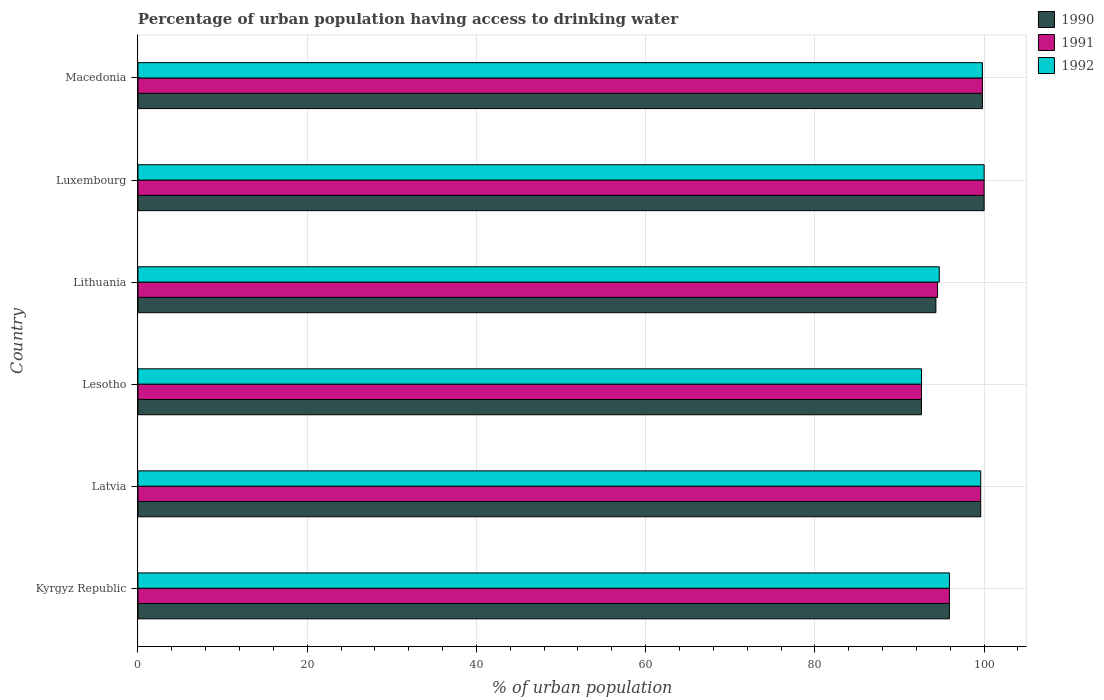How many groups of bars are there?
Provide a short and direct response. 6. Are the number of bars per tick equal to the number of legend labels?
Offer a very short reply. Yes. Are the number of bars on each tick of the Y-axis equal?
Make the answer very short. Yes. How many bars are there on the 3rd tick from the bottom?
Ensure brevity in your answer.  3. What is the label of the 4th group of bars from the top?
Provide a short and direct response. Lesotho. In how many cases, is the number of bars for a given country not equal to the number of legend labels?
Your response must be concise. 0. What is the percentage of urban population having access to drinking water in 1990 in Lithuania?
Ensure brevity in your answer.  94.3. Across all countries, what is the minimum percentage of urban population having access to drinking water in 1991?
Keep it short and to the point. 92.6. In which country was the percentage of urban population having access to drinking water in 1991 maximum?
Your answer should be compact. Luxembourg. In which country was the percentage of urban population having access to drinking water in 1992 minimum?
Make the answer very short. Lesotho. What is the total percentage of urban population having access to drinking water in 1990 in the graph?
Your answer should be very brief. 582.2. What is the difference between the percentage of urban population having access to drinking water in 1990 in Latvia and that in Lithuania?
Give a very brief answer. 5.3. What is the difference between the percentage of urban population having access to drinking water in 1991 in Macedonia and the percentage of urban population having access to drinking water in 1990 in Lithuania?
Your answer should be very brief. 5.5. What is the average percentage of urban population having access to drinking water in 1990 per country?
Ensure brevity in your answer.  97.03. What is the difference between the percentage of urban population having access to drinking water in 1990 and percentage of urban population having access to drinking water in 1991 in Macedonia?
Provide a short and direct response. 0. In how many countries, is the percentage of urban population having access to drinking water in 1990 greater than 76 %?
Your response must be concise. 6. What is the ratio of the percentage of urban population having access to drinking water in 1992 in Luxembourg to that in Macedonia?
Provide a succinct answer. 1. Is the difference between the percentage of urban population having access to drinking water in 1990 in Latvia and Lithuania greater than the difference between the percentage of urban population having access to drinking water in 1991 in Latvia and Lithuania?
Your answer should be very brief. Yes. What is the difference between the highest and the second highest percentage of urban population having access to drinking water in 1992?
Make the answer very short. 0.2. What is the difference between the highest and the lowest percentage of urban population having access to drinking water in 1991?
Your answer should be very brief. 7.4. In how many countries, is the percentage of urban population having access to drinking water in 1990 greater than the average percentage of urban population having access to drinking water in 1990 taken over all countries?
Ensure brevity in your answer.  3. Is the sum of the percentage of urban population having access to drinking water in 1991 in Lithuania and Luxembourg greater than the maximum percentage of urban population having access to drinking water in 1992 across all countries?
Provide a succinct answer. Yes. What does the 1st bar from the bottom in Luxembourg represents?
Your response must be concise. 1990. Is it the case that in every country, the sum of the percentage of urban population having access to drinking water in 1990 and percentage of urban population having access to drinking water in 1991 is greater than the percentage of urban population having access to drinking water in 1992?
Give a very brief answer. Yes. Are all the bars in the graph horizontal?
Offer a very short reply. Yes. How many countries are there in the graph?
Offer a terse response. 6. Are the values on the major ticks of X-axis written in scientific E-notation?
Your answer should be very brief. No. Does the graph contain any zero values?
Your response must be concise. No. What is the title of the graph?
Provide a succinct answer. Percentage of urban population having access to drinking water. What is the label or title of the X-axis?
Give a very brief answer. % of urban population. What is the label or title of the Y-axis?
Provide a succinct answer. Country. What is the % of urban population in 1990 in Kyrgyz Republic?
Your response must be concise. 95.9. What is the % of urban population of 1991 in Kyrgyz Republic?
Provide a succinct answer. 95.9. What is the % of urban population in 1992 in Kyrgyz Republic?
Provide a short and direct response. 95.9. What is the % of urban population of 1990 in Latvia?
Give a very brief answer. 99.6. What is the % of urban population in 1991 in Latvia?
Your answer should be very brief. 99.6. What is the % of urban population in 1992 in Latvia?
Offer a terse response. 99.6. What is the % of urban population in 1990 in Lesotho?
Your answer should be compact. 92.6. What is the % of urban population in 1991 in Lesotho?
Give a very brief answer. 92.6. What is the % of urban population of 1992 in Lesotho?
Offer a very short reply. 92.6. What is the % of urban population in 1990 in Lithuania?
Offer a terse response. 94.3. What is the % of urban population in 1991 in Lithuania?
Ensure brevity in your answer.  94.5. What is the % of urban population in 1992 in Lithuania?
Offer a terse response. 94.7. What is the % of urban population in 1990 in Macedonia?
Your answer should be very brief. 99.8. What is the % of urban population in 1991 in Macedonia?
Offer a terse response. 99.8. What is the % of urban population in 1992 in Macedonia?
Provide a short and direct response. 99.8. Across all countries, what is the maximum % of urban population of 1991?
Give a very brief answer. 100. Across all countries, what is the maximum % of urban population of 1992?
Provide a succinct answer. 100. Across all countries, what is the minimum % of urban population in 1990?
Offer a very short reply. 92.6. Across all countries, what is the minimum % of urban population in 1991?
Offer a terse response. 92.6. Across all countries, what is the minimum % of urban population in 1992?
Offer a very short reply. 92.6. What is the total % of urban population in 1990 in the graph?
Ensure brevity in your answer.  582.2. What is the total % of urban population in 1991 in the graph?
Provide a succinct answer. 582.4. What is the total % of urban population in 1992 in the graph?
Your response must be concise. 582.6. What is the difference between the % of urban population of 1991 in Kyrgyz Republic and that in Latvia?
Provide a succinct answer. -3.7. What is the difference between the % of urban population of 1990 in Kyrgyz Republic and that in Lesotho?
Make the answer very short. 3.3. What is the difference between the % of urban population of 1990 in Kyrgyz Republic and that in Lithuania?
Offer a terse response. 1.6. What is the difference between the % of urban population of 1991 in Kyrgyz Republic and that in Lithuania?
Your answer should be very brief. 1.4. What is the difference between the % of urban population of 1990 in Kyrgyz Republic and that in Luxembourg?
Offer a terse response. -4.1. What is the difference between the % of urban population of 1990 in Kyrgyz Republic and that in Macedonia?
Your answer should be very brief. -3.9. What is the difference between the % of urban population in 1991 in Kyrgyz Republic and that in Macedonia?
Your response must be concise. -3.9. What is the difference between the % of urban population in 1991 in Latvia and that in Lesotho?
Provide a succinct answer. 7. What is the difference between the % of urban population in 1992 in Latvia and that in Lesotho?
Make the answer very short. 7. What is the difference between the % of urban population of 1990 in Latvia and that in Lithuania?
Your response must be concise. 5.3. What is the difference between the % of urban population in 1991 in Latvia and that in Lithuania?
Offer a very short reply. 5.1. What is the difference between the % of urban population of 1990 in Latvia and that in Luxembourg?
Offer a terse response. -0.4. What is the difference between the % of urban population in 1991 in Latvia and that in Luxembourg?
Offer a very short reply. -0.4. What is the difference between the % of urban population in 1992 in Latvia and that in Luxembourg?
Your answer should be very brief. -0.4. What is the difference between the % of urban population in 1990 in Latvia and that in Macedonia?
Ensure brevity in your answer.  -0.2. What is the difference between the % of urban population in 1992 in Latvia and that in Macedonia?
Provide a short and direct response. -0.2. What is the difference between the % of urban population of 1992 in Lesotho and that in Lithuania?
Your response must be concise. -2.1. What is the difference between the % of urban population in 1991 in Lesotho and that in Luxembourg?
Your answer should be compact. -7.4. What is the difference between the % of urban population in 1992 in Lesotho and that in Luxembourg?
Provide a succinct answer. -7.4. What is the difference between the % of urban population in 1990 in Lesotho and that in Macedonia?
Offer a terse response. -7.2. What is the difference between the % of urban population of 1991 in Lesotho and that in Macedonia?
Your answer should be very brief. -7.2. What is the difference between the % of urban population of 1992 in Lesotho and that in Macedonia?
Provide a succinct answer. -7.2. What is the difference between the % of urban population of 1991 in Lithuania and that in Luxembourg?
Give a very brief answer. -5.5. What is the difference between the % of urban population of 1990 in Lithuania and that in Macedonia?
Keep it short and to the point. -5.5. What is the difference between the % of urban population of 1990 in Luxembourg and that in Macedonia?
Offer a very short reply. 0.2. What is the difference between the % of urban population of 1991 in Luxembourg and that in Macedonia?
Make the answer very short. 0.2. What is the difference between the % of urban population of 1992 in Luxembourg and that in Macedonia?
Make the answer very short. 0.2. What is the difference between the % of urban population of 1990 in Kyrgyz Republic and the % of urban population of 1991 in Latvia?
Ensure brevity in your answer.  -3.7. What is the difference between the % of urban population in 1990 in Kyrgyz Republic and the % of urban population in 1992 in Latvia?
Offer a very short reply. -3.7. What is the difference between the % of urban population of 1990 in Kyrgyz Republic and the % of urban population of 1991 in Lesotho?
Ensure brevity in your answer.  3.3. What is the difference between the % of urban population in 1991 in Kyrgyz Republic and the % of urban population in 1992 in Lesotho?
Provide a short and direct response. 3.3. What is the difference between the % of urban population of 1991 in Kyrgyz Republic and the % of urban population of 1992 in Lithuania?
Make the answer very short. 1.2. What is the difference between the % of urban population in 1990 in Kyrgyz Republic and the % of urban population in 1991 in Luxembourg?
Your answer should be very brief. -4.1. What is the difference between the % of urban population in 1990 in Kyrgyz Republic and the % of urban population in 1991 in Macedonia?
Offer a terse response. -3.9. What is the difference between the % of urban population in 1990 in Kyrgyz Republic and the % of urban population in 1992 in Macedonia?
Offer a terse response. -3.9. What is the difference between the % of urban population in 1990 in Latvia and the % of urban population in 1992 in Lesotho?
Your answer should be very brief. 7. What is the difference between the % of urban population in 1991 in Latvia and the % of urban population in 1992 in Lesotho?
Your answer should be compact. 7. What is the difference between the % of urban population in 1990 in Latvia and the % of urban population in 1991 in Lithuania?
Offer a terse response. 5.1. What is the difference between the % of urban population of 1990 in Latvia and the % of urban population of 1992 in Lithuania?
Make the answer very short. 4.9. What is the difference between the % of urban population of 1990 in Latvia and the % of urban population of 1991 in Luxembourg?
Your response must be concise. -0.4. What is the difference between the % of urban population in 1990 in Latvia and the % of urban population in 1992 in Luxembourg?
Your answer should be compact. -0.4. What is the difference between the % of urban population of 1991 in Latvia and the % of urban population of 1992 in Macedonia?
Ensure brevity in your answer.  -0.2. What is the difference between the % of urban population of 1990 in Lesotho and the % of urban population of 1991 in Lithuania?
Offer a very short reply. -1.9. What is the difference between the % of urban population in 1990 in Lesotho and the % of urban population in 1992 in Lithuania?
Your answer should be compact. -2.1. What is the difference between the % of urban population in 1991 in Lesotho and the % of urban population in 1992 in Lithuania?
Keep it short and to the point. -2.1. What is the difference between the % of urban population of 1990 in Lesotho and the % of urban population of 1992 in Luxembourg?
Ensure brevity in your answer.  -7.4. What is the difference between the % of urban population in 1991 in Lesotho and the % of urban population in 1992 in Luxembourg?
Give a very brief answer. -7.4. What is the difference between the % of urban population of 1990 in Lesotho and the % of urban population of 1992 in Macedonia?
Provide a short and direct response. -7.2. What is the difference between the % of urban population in 1991 in Lesotho and the % of urban population in 1992 in Macedonia?
Keep it short and to the point. -7.2. What is the difference between the % of urban population of 1990 in Lithuania and the % of urban population of 1992 in Macedonia?
Provide a short and direct response. -5.5. What is the difference between the % of urban population of 1991 in Lithuania and the % of urban population of 1992 in Macedonia?
Give a very brief answer. -5.3. What is the difference between the % of urban population of 1990 in Luxembourg and the % of urban population of 1991 in Macedonia?
Provide a short and direct response. 0.2. What is the difference between the % of urban population of 1990 in Luxembourg and the % of urban population of 1992 in Macedonia?
Keep it short and to the point. 0.2. What is the average % of urban population of 1990 per country?
Provide a succinct answer. 97.03. What is the average % of urban population of 1991 per country?
Your answer should be very brief. 97.07. What is the average % of urban population in 1992 per country?
Keep it short and to the point. 97.1. What is the difference between the % of urban population of 1990 and % of urban population of 1992 in Kyrgyz Republic?
Make the answer very short. 0. What is the difference between the % of urban population of 1990 and % of urban population of 1991 in Latvia?
Ensure brevity in your answer.  0. What is the difference between the % of urban population of 1990 and % of urban population of 1992 in Latvia?
Ensure brevity in your answer.  0. What is the difference between the % of urban population in 1991 and % of urban population in 1992 in Latvia?
Make the answer very short. 0. What is the difference between the % of urban population of 1990 and % of urban population of 1991 in Lesotho?
Your response must be concise. 0. What is the difference between the % of urban population in 1990 and % of urban population in 1992 in Lesotho?
Offer a terse response. 0. What is the difference between the % of urban population in 1990 and % of urban population in 1992 in Lithuania?
Your response must be concise. -0.4. What is the difference between the % of urban population of 1991 and % of urban population of 1992 in Lithuania?
Provide a succinct answer. -0.2. What is the difference between the % of urban population of 1990 and % of urban population of 1992 in Luxembourg?
Provide a short and direct response. 0. What is the difference between the % of urban population of 1991 and % of urban population of 1992 in Luxembourg?
Your answer should be compact. 0. What is the difference between the % of urban population of 1991 and % of urban population of 1992 in Macedonia?
Your response must be concise. 0. What is the ratio of the % of urban population of 1990 in Kyrgyz Republic to that in Latvia?
Make the answer very short. 0.96. What is the ratio of the % of urban population in 1991 in Kyrgyz Republic to that in Latvia?
Your answer should be very brief. 0.96. What is the ratio of the % of urban population in 1992 in Kyrgyz Republic to that in Latvia?
Offer a very short reply. 0.96. What is the ratio of the % of urban population of 1990 in Kyrgyz Republic to that in Lesotho?
Offer a very short reply. 1.04. What is the ratio of the % of urban population in 1991 in Kyrgyz Republic to that in Lesotho?
Provide a short and direct response. 1.04. What is the ratio of the % of urban population in 1992 in Kyrgyz Republic to that in Lesotho?
Keep it short and to the point. 1.04. What is the ratio of the % of urban population in 1991 in Kyrgyz Republic to that in Lithuania?
Your response must be concise. 1.01. What is the ratio of the % of urban population in 1992 in Kyrgyz Republic to that in Lithuania?
Provide a succinct answer. 1.01. What is the ratio of the % of urban population in 1990 in Kyrgyz Republic to that in Luxembourg?
Make the answer very short. 0.96. What is the ratio of the % of urban population in 1991 in Kyrgyz Republic to that in Luxembourg?
Keep it short and to the point. 0.96. What is the ratio of the % of urban population of 1990 in Kyrgyz Republic to that in Macedonia?
Your answer should be very brief. 0.96. What is the ratio of the % of urban population of 1991 in Kyrgyz Republic to that in Macedonia?
Make the answer very short. 0.96. What is the ratio of the % of urban population in 1992 in Kyrgyz Republic to that in Macedonia?
Your response must be concise. 0.96. What is the ratio of the % of urban population in 1990 in Latvia to that in Lesotho?
Ensure brevity in your answer.  1.08. What is the ratio of the % of urban population in 1991 in Latvia to that in Lesotho?
Keep it short and to the point. 1.08. What is the ratio of the % of urban population of 1992 in Latvia to that in Lesotho?
Give a very brief answer. 1.08. What is the ratio of the % of urban population in 1990 in Latvia to that in Lithuania?
Ensure brevity in your answer.  1.06. What is the ratio of the % of urban population of 1991 in Latvia to that in Lithuania?
Provide a succinct answer. 1.05. What is the ratio of the % of urban population in 1992 in Latvia to that in Lithuania?
Provide a succinct answer. 1.05. What is the ratio of the % of urban population of 1992 in Latvia to that in Macedonia?
Keep it short and to the point. 1. What is the ratio of the % of urban population of 1990 in Lesotho to that in Lithuania?
Make the answer very short. 0.98. What is the ratio of the % of urban population of 1991 in Lesotho to that in Lithuania?
Your response must be concise. 0.98. What is the ratio of the % of urban population of 1992 in Lesotho to that in Lithuania?
Offer a very short reply. 0.98. What is the ratio of the % of urban population of 1990 in Lesotho to that in Luxembourg?
Make the answer very short. 0.93. What is the ratio of the % of urban population in 1991 in Lesotho to that in Luxembourg?
Keep it short and to the point. 0.93. What is the ratio of the % of urban population of 1992 in Lesotho to that in Luxembourg?
Your response must be concise. 0.93. What is the ratio of the % of urban population in 1990 in Lesotho to that in Macedonia?
Your answer should be very brief. 0.93. What is the ratio of the % of urban population in 1991 in Lesotho to that in Macedonia?
Keep it short and to the point. 0.93. What is the ratio of the % of urban population in 1992 in Lesotho to that in Macedonia?
Provide a short and direct response. 0.93. What is the ratio of the % of urban population in 1990 in Lithuania to that in Luxembourg?
Provide a succinct answer. 0.94. What is the ratio of the % of urban population of 1991 in Lithuania to that in Luxembourg?
Make the answer very short. 0.94. What is the ratio of the % of urban population in 1992 in Lithuania to that in Luxembourg?
Offer a very short reply. 0.95. What is the ratio of the % of urban population of 1990 in Lithuania to that in Macedonia?
Ensure brevity in your answer.  0.94. What is the ratio of the % of urban population of 1991 in Lithuania to that in Macedonia?
Your answer should be very brief. 0.95. What is the ratio of the % of urban population in 1992 in Lithuania to that in Macedonia?
Offer a terse response. 0.95. What is the ratio of the % of urban population of 1991 in Luxembourg to that in Macedonia?
Make the answer very short. 1. What is the difference between the highest and the second highest % of urban population of 1992?
Provide a succinct answer. 0.2. What is the difference between the highest and the lowest % of urban population of 1991?
Offer a very short reply. 7.4. 